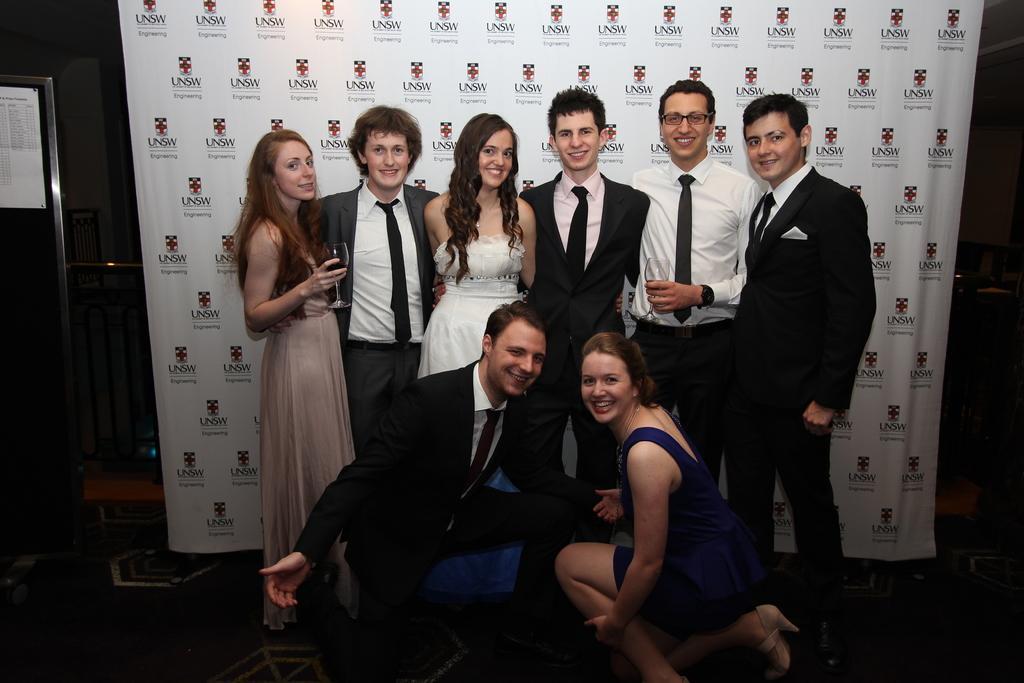In one or two sentences, can you explain what this image depicts? Here we can see a man and woman on a stage in squat position and behind them there are six persons standing on the stage where a woman and man are holding a glass in their hand. In the background there is a hoarding,paper on the notice board and we can see some other objects. 